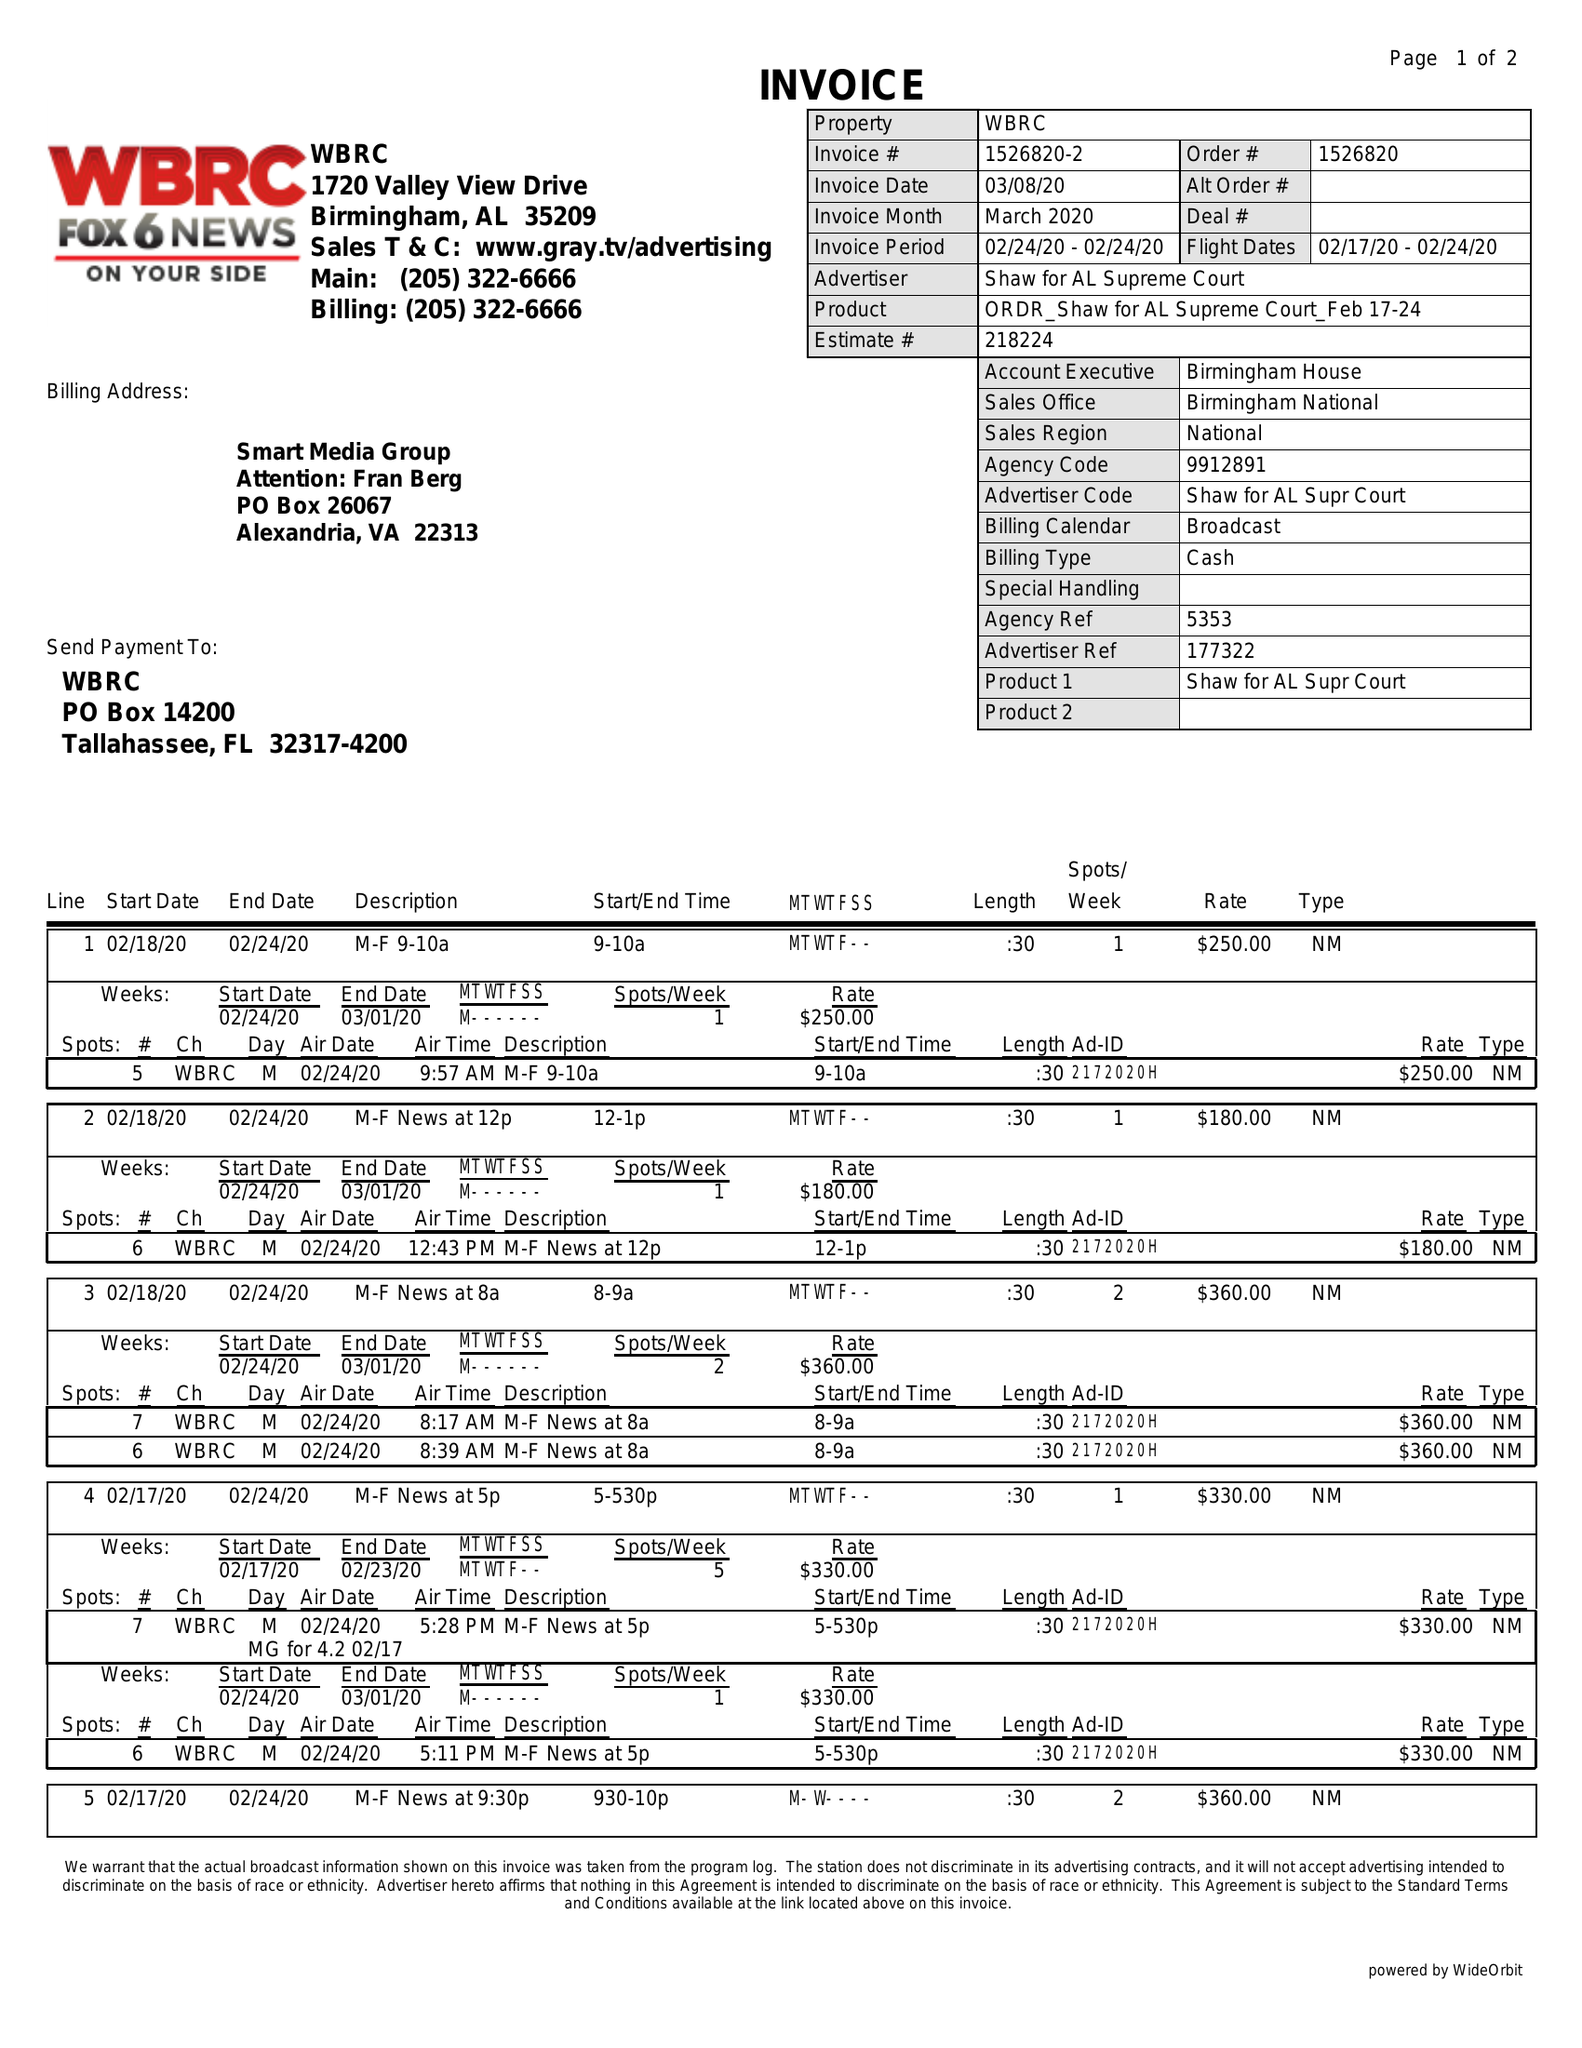What is the value for the advertiser?
Answer the question using a single word or phrase. SHAW FOR AL SUPREME COURT 